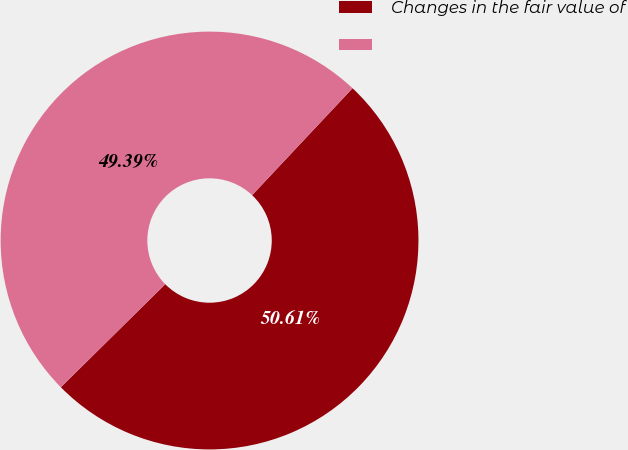Convert chart to OTSL. <chart><loc_0><loc_0><loc_500><loc_500><pie_chart><fcel>Changes in the fair value of<fcel>Unnamed: 1<nl><fcel>50.61%<fcel>49.39%<nl></chart> 